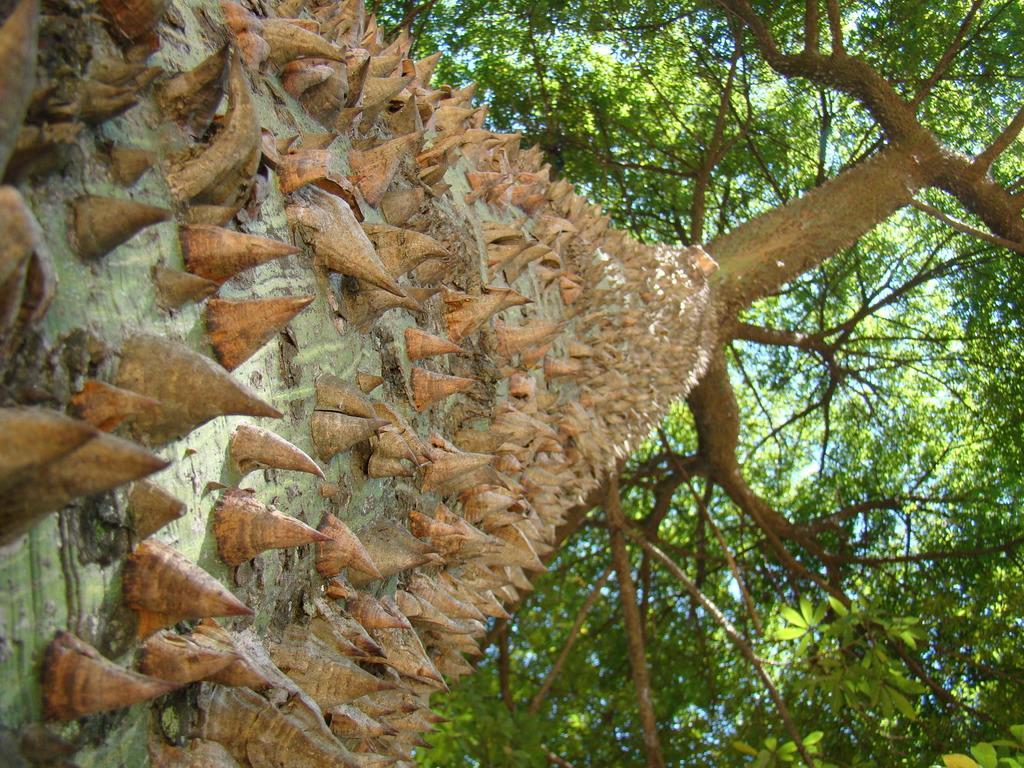How would you summarize this image in a sentence or two? In this I can see trees and I can see spikes to the tree bark. 